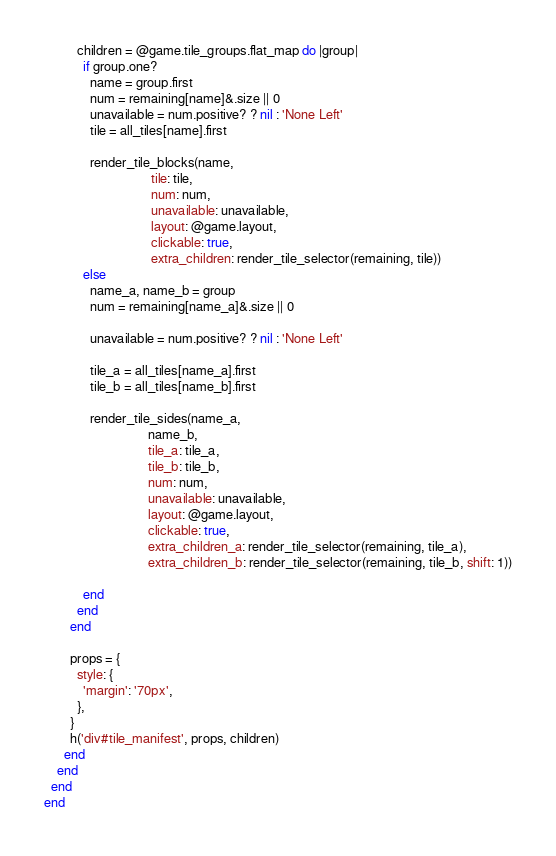Convert code to text. <code><loc_0><loc_0><loc_500><loc_500><_Ruby_>          children = @game.tile_groups.flat_map do |group|
            if group.one?
              name = group.first
              num = remaining[name]&.size || 0
              unavailable = num.positive? ? nil : 'None Left'
              tile = all_tiles[name].first

              render_tile_blocks(name,
                                 tile: tile,
                                 num: num,
                                 unavailable: unavailable,
                                 layout: @game.layout,
                                 clickable: true,
                                 extra_children: render_tile_selector(remaining, tile))
            else
              name_a, name_b = group
              num = remaining[name_a]&.size || 0

              unavailable = num.positive? ? nil : 'None Left'

              tile_a = all_tiles[name_a].first
              tile_b = all_tiles[name_b].first

              render_tile_sides(name_a,
                                name_b,
                                tile_a: tile_a,
                                tile_b: tile_b,
                                num: num,
                                unavailable: unavailable,
                                layout: @game.layout,
                                clickable: true,
                                extra_children_a: render_tile_selector(remaining, tile_a),
                                extra_children_b: render_tile_selector(remaining, tile_b, shift: 1))

            end
          end
        end

        props = {
          style: {
            'margin': '70px',
          },
        }
        h('div#tile_manifest', props, children)
      end
    end
  end
end
</code> 